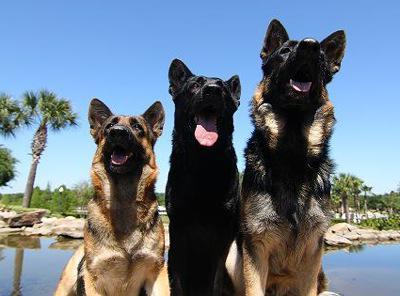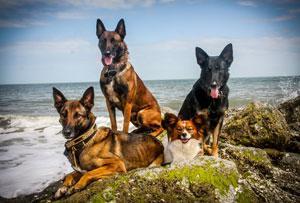The first image is the image on the left, the second image is the image on the right. Given the left and right images, does the statement "An image shows dogs posed on a wooden bench." hold true? Answer yes or no. No. 